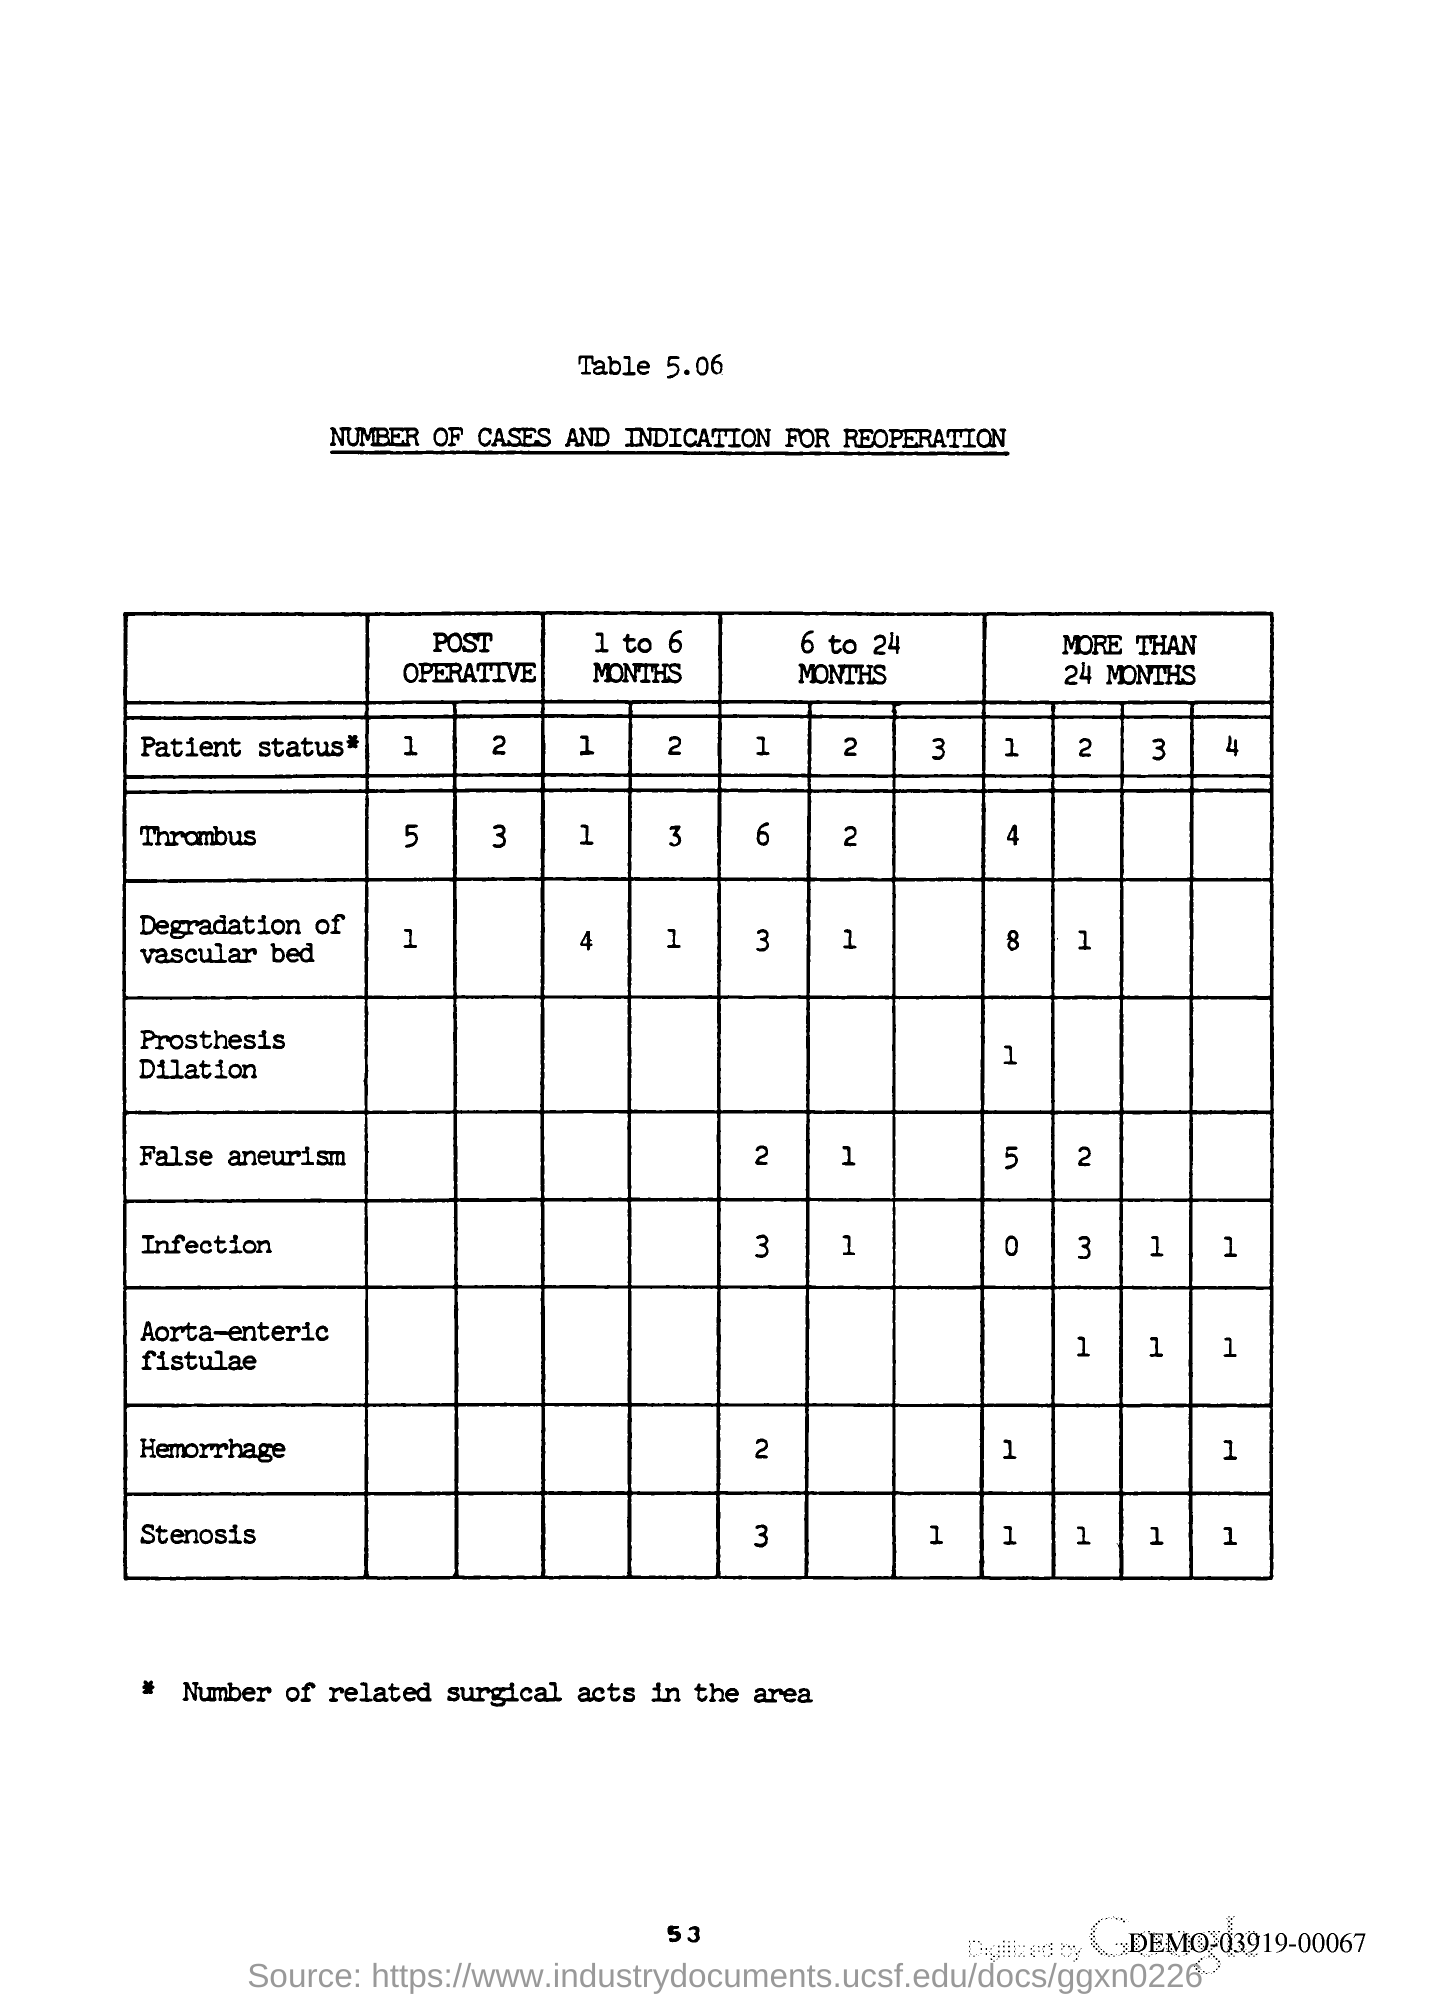What is the title of the table 5.06?
Give a very brief answer. Number of Cases and Indication for Reoperation. What is the Page Number?
Offer a very short reply. 53. 